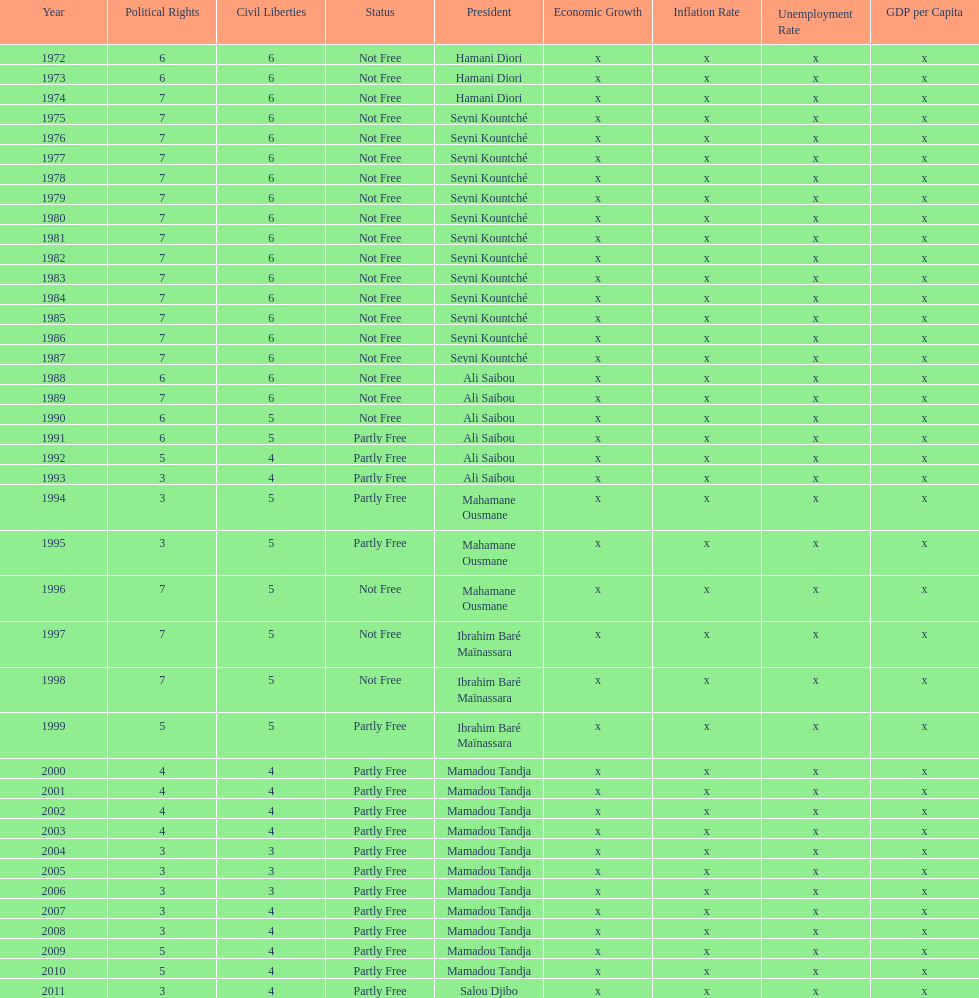Who was president before mamadou tandja? Ibrahim Baré Maïnassara. 